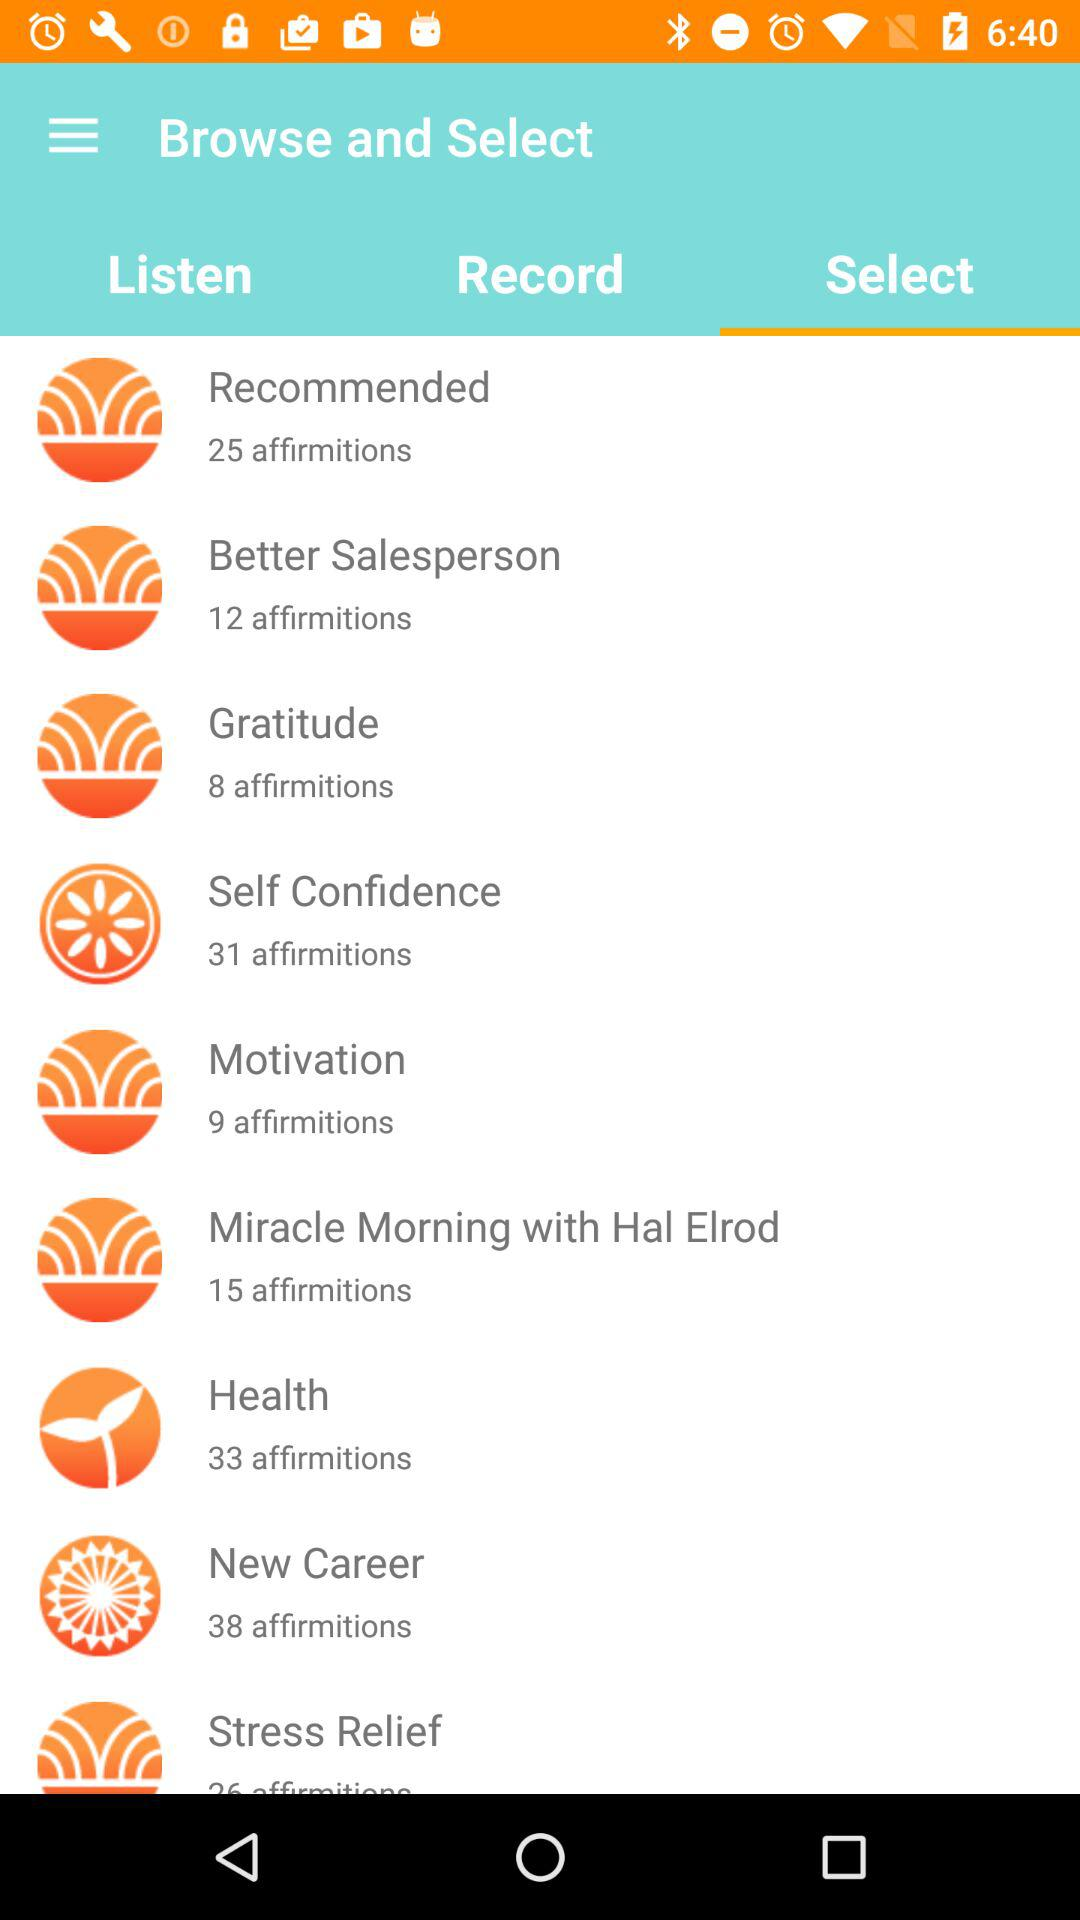How many affirmitions are there for motivation? There are 9 affirmitions for motivation. 